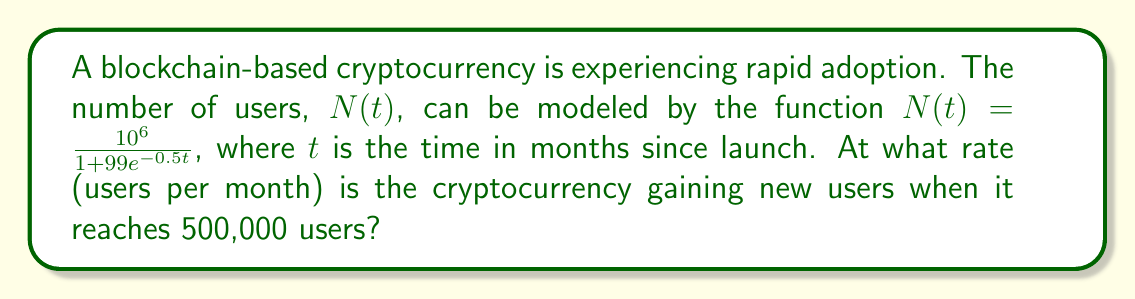Help me with this question. To solve this problem, we'll follow these steps:

1) First, we need to find the time $t$ when the number of users reaches 500,000.

2) Then, we'll calculate the rate of change (derivative) of $N(t)$ at that time.

Step 1: Finding $t$ when $N(t) = 500,000$

We solve the equation:

$$\frac{10^6}{1 + 99e^{-0.5t}} = 500,000$$

$$2 = 1 + 99e^{-0.5t}$$

$$1 = 99e^{-0.5t}$$

$$e^{-0.5t} = \frac{1}{99}$$

$$-0.5t = \ln(\frac{1}{99})$$

$$t = -2\ln(\frac{1}{99}) \approx 9.19 \text{ months}$$

Step 2: Calculating the rate of change at $t \approx 9.19$

We need to find $\frac{dN}{dt}$ at $t \approx 9.19$.

First, let's derive $\frac{dN}{dt}$:

$$\frac{dN}{dt} = \frac{10^6 \cdot 99 \cdot 0.5e^{-0.5t}}{(1 + 99e^{-0.5t})^2}$$

Now, we substitute $t \approx 9.19$:

$$\frac{dN}{dt} \approx \frac{10^6 \cdot 99 \cdot 0.5e^{-0.5(9.19)}}{(1 + 99e^{-0.5(9.19)})^2}$$

$$\approx \frac{10^6 \cdot 99 \cdot 0.5 \cdot 0.0101}{(1 + 99 \cdot 0.0101)^2}$$

$$\approx \frac{500,000}{4} = 125,000$$

Therefore, when the cryptocurrency reaches 500,000 users, it's gaining approximately 125,000 new users per month.
Answer: 125,000 users per month 